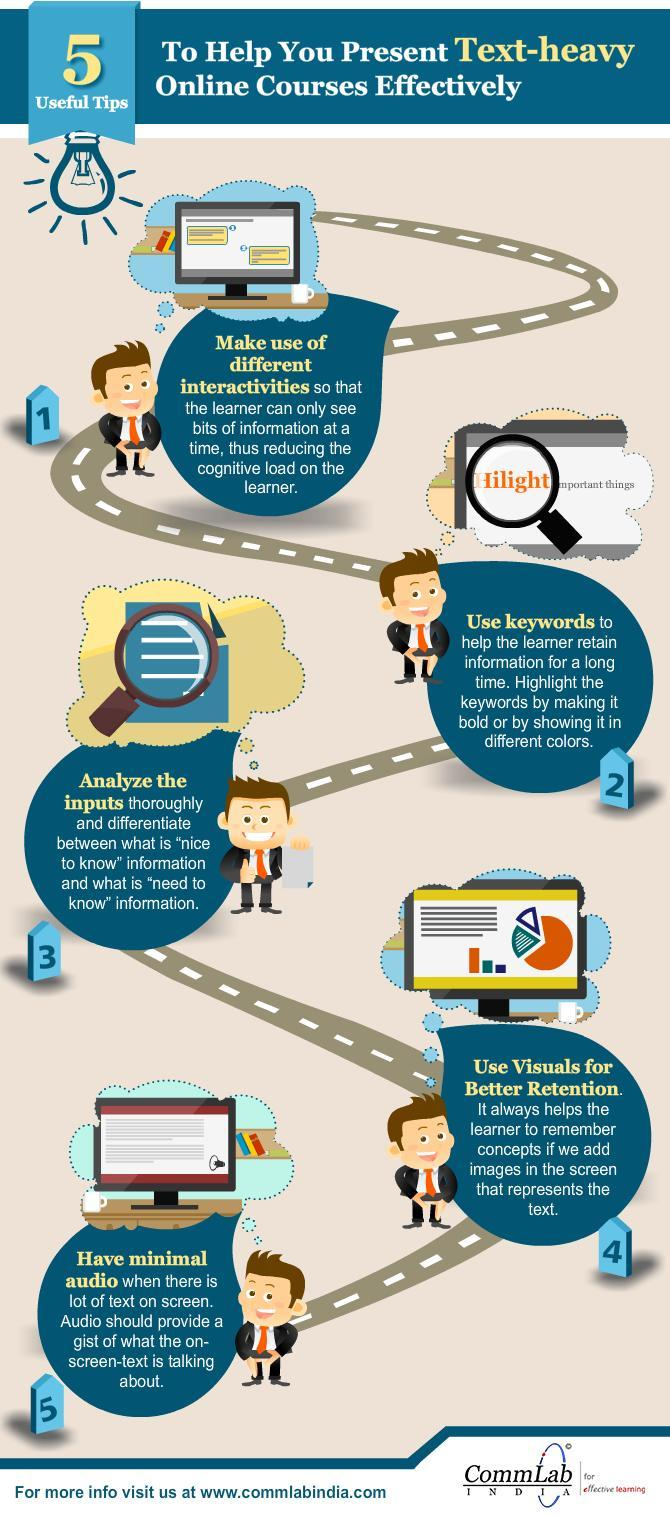How many numbers of search icons are in this infographic?
Answer the question with a short phrase. 2 